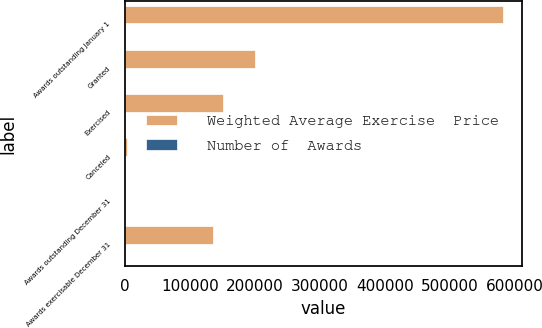<chart> <loc_0><loc_0><loc_500><loc_500><stacked_bar_chart><ecel><fcel>Awards outstanding January 1<fcel>Granted<fcel>Exercised<fcel>Canceled<fcel>Awards outstanding December 31<fcel>Awards exercisable December 31<nl><fcel>Weighted Average Exercise  Price<fcel>581694<fcel>200500<fcel>150366<fcel>3500<fcel>74.63<fcel>136304<nl><fcel>Number of  Awards<fcel>36.24<fcel>74.63<fcel>30.68<fcel>44.18<fcel>49.78<fcel>32.51<nl></chart> 